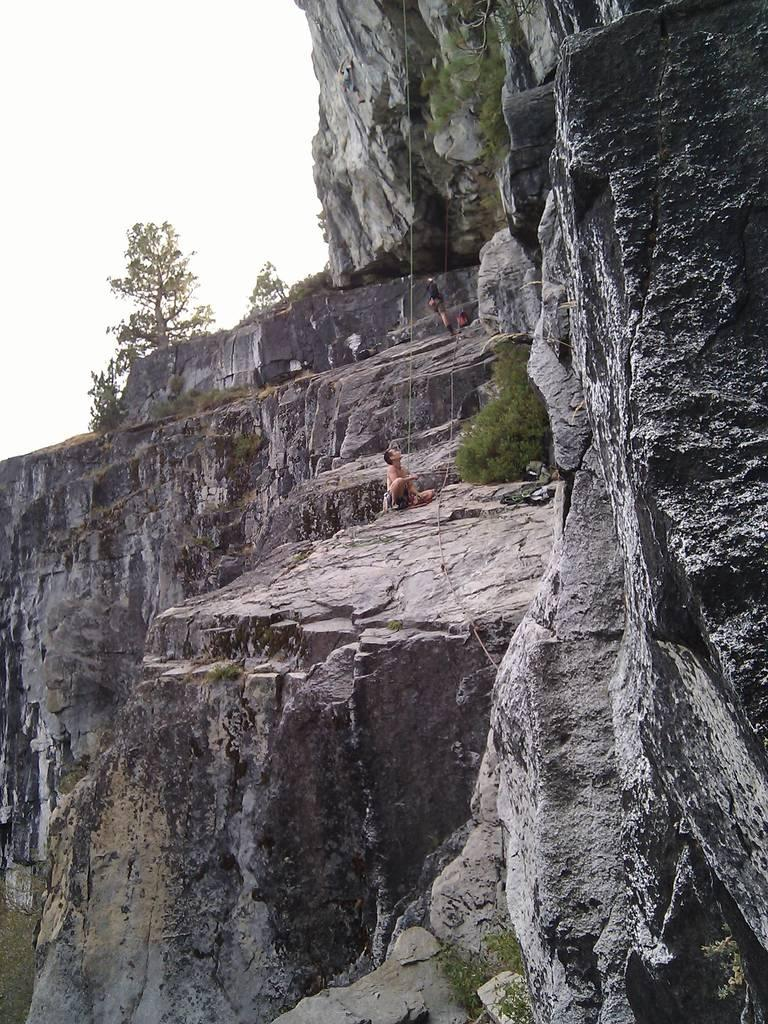What is the prominent feature in the image? There is a huge hill in the image. What are the people in the image doing? The people are holding ropes in the image. How are the ropes connected to the hill? The ropes are tied to the hill. What can be seen in the background of the image? There are trees in the background of the image. What type of rule is being enforced by the goldfish in the image? There is no goldfish present in the image, so no rule is being enforced. What color is the underwear worn by the people holding ropes in the image? The provided facts do not mention any clothing, including underwear, so we cannot determine the color. 